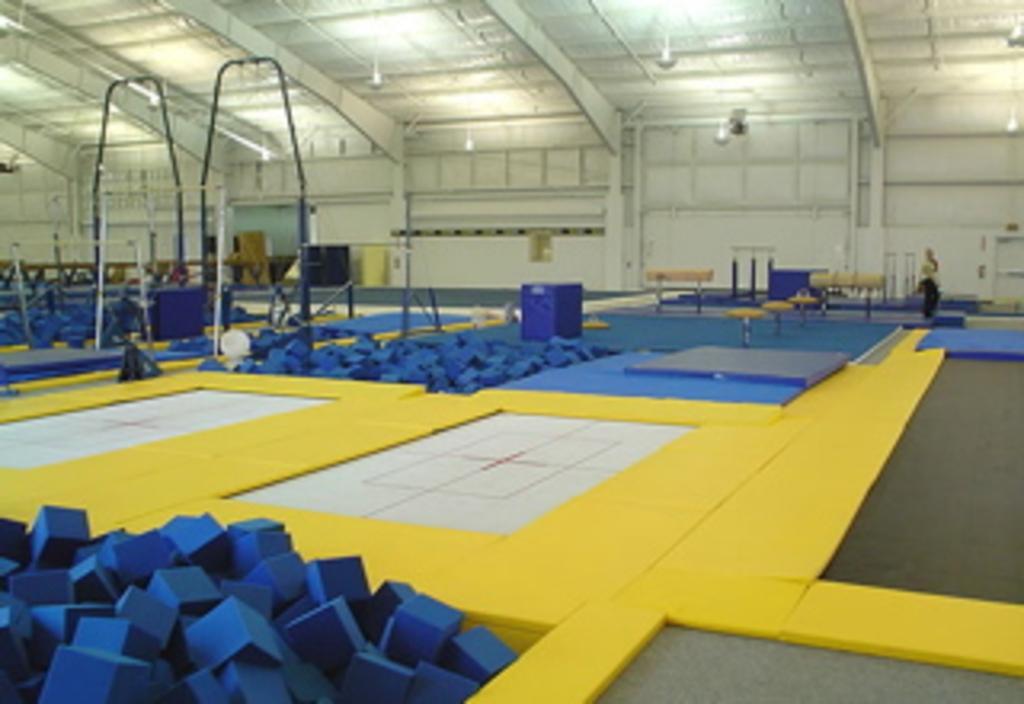Describe this image in one or two sentences. In the picture it looks like the sky zone there are many trampolines and sponge boxes. 